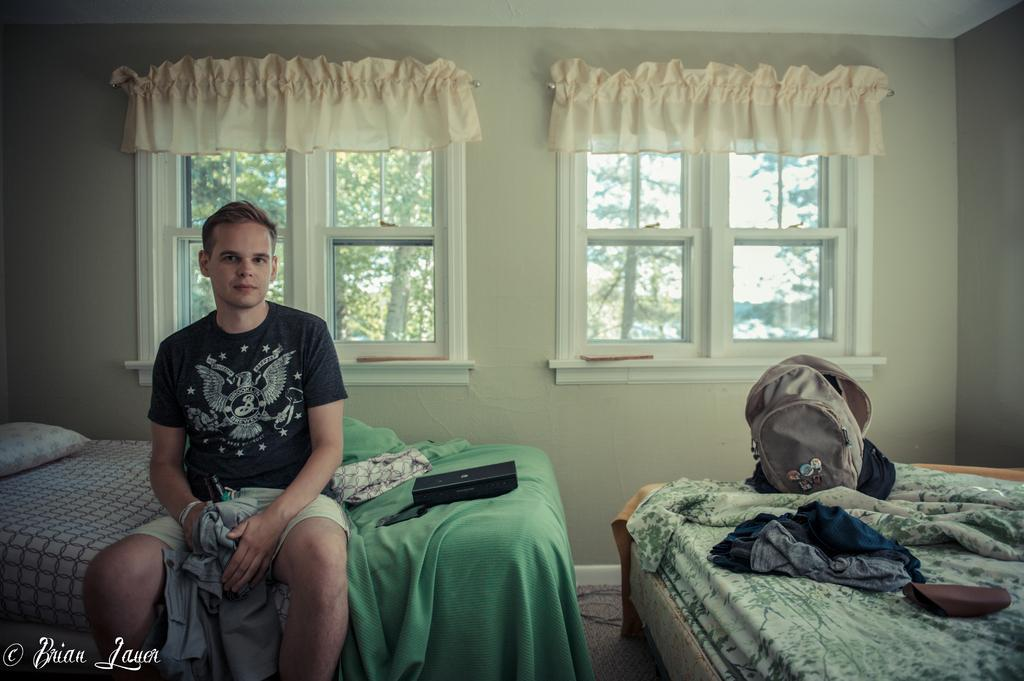What is the main subject of the image? There is a person in the image. What is the person wearing? The person is wearing a black shirt. Where is the person located in the image? The person is sitting on a bed. What is the person holding in the image? The person is holding a bottle. What is associated with the bottle? There is a cloth associated with the bottle. What can be seen in the background of the image? There are windows visible in the image. What flavor of end can be seen in the image? There is no end present in the image, and therefore no flavor can be determined. How many spiders are crawling on the person in the image? There are no spiders visible in the image. 